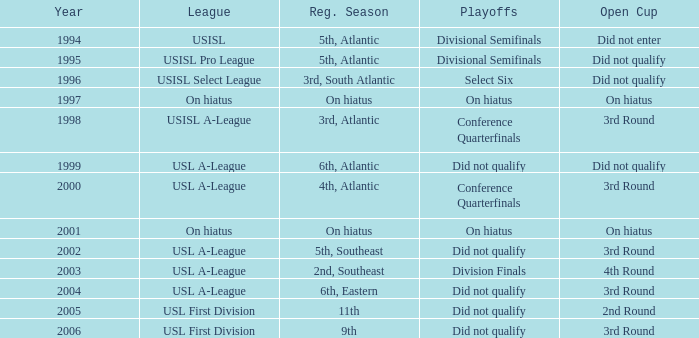What was the earliest year for the USISL Pro League? 1995.0. 